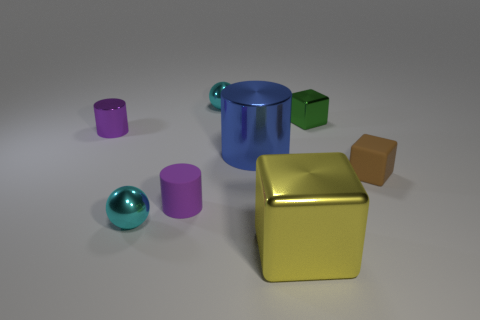Is there anything else that has the same shape as the small brown matte object?
Your answer should be compact. Yes. The tiny metallic object to the right of the tiny sphere that is to the right of the small shiny object in front of the blue metal cylinder is what color?
Offer a very short reply. Green. What shape is the tiny thing that is both on the right side of the large blue shiny cylinder and to the left of the brown rubber object?
Your response must be concise. Cube. Is there any other thing that is the same size as the yellow object?
Your response must be concise. Yes. There is a rubber object that is on the left side of the small shiny thing that is behind the green metal thing; what is its color?
Give a very brief answer. Purple. There is a large thing that is behind the tiny rubber object that is on the right side of the large thing that is to the right of the big cylinder; what shape is it?
Provide a succinct answer. Cylinder. There is a metallic object that is both on the left side of the large blue thing and in front of the tiny purple metal cylinder; what size is it?
Your answer should be compact. Small. What number of shiny things have the same color as the small matte cylinder?
Provide a succinct answer. 1. What material is the object that is the same color as the tiny matte cylinder?
Provide a short and direct response. Metal. What material is the tiny green block?
Your answer should be compact. Metal. 